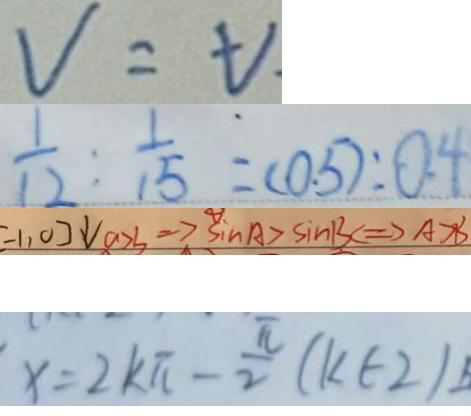<formula> <loc_0><loc_0><loc_500><loc_500>V = t 
 \frac { 1 } { 1 2 } : \frac { 1 } { 1 5 } = ( 0 . 5 ) : 0 . 4 
 - 1 , 0 ] \downarrow a > 3 \Rightarrow A > \sin A > \sin B C \Rightarrow A > B 
 x = 2 k \pi - \frac { \pi } { 2 } ( k \in 2 )</formula> 